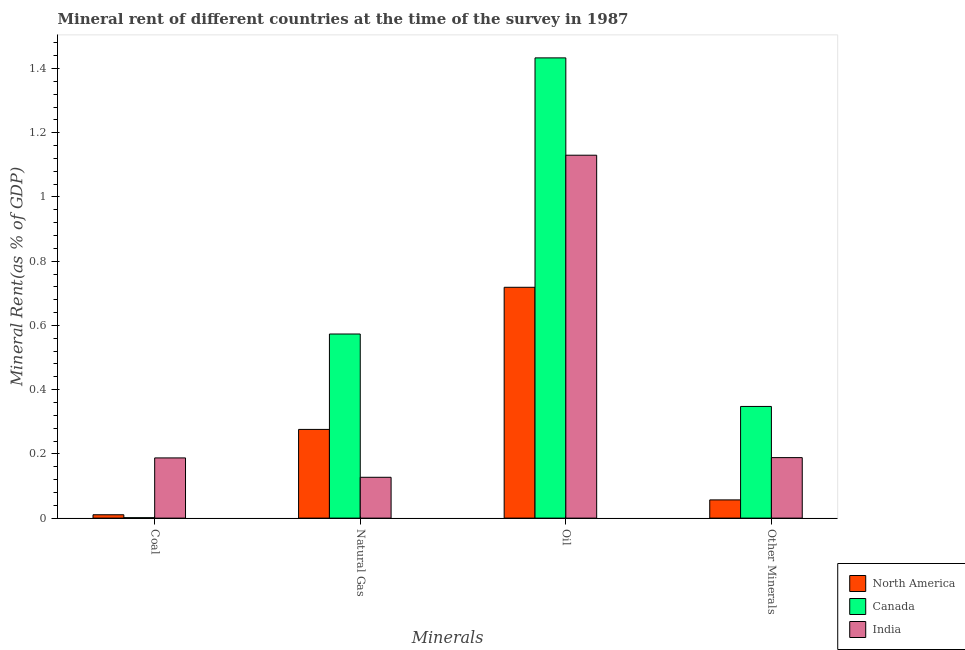How many groups of bars are there?
Your answer should be very brief. 4. Are the number of bars per tick equal to the number of legend labels?
Your answer should be very brief. Yes. How many bars are there on the 1st tick from the left?
Ensure brevity in your answer.  3. What is the label of the 3rd group of bars from the left?
Keep it short and to the point. Oil. What is the  rent of other minerals in Canada?
Give a very brief answer. 0.35. Across all countries, what is the maximum  rent of other minerals?
Ensure brevity in your answer.  0.35. Across all countries, what is the minimum coal rent?
Your answer should be very brief. 0. In which country was the coal rent minimum?
Offer a very short reply. Canada. What is the total coal rent in the graph?
Offer a terse response. 0.2. What is the difference between the coal rent in North America and that in India?
Your answer should be very brief. -0.18. What is the difference between the  rent of other minerals in India and the oil rent in North America?
Offer a very short reply. -0.53. What is the average  rent of other minerals per country?
Your answer should be compact. 0.2. What is the difference between the natural gas rent and  rent of other minerals in India?
Ensure brevity in your answer.  -0.06. What is the ratio of the oil rent in Canada to that in North America?
Provide a short and direct response. 1.99. Is the coal rent in North America less than that in Canada?
Keep it short and to the point. No. Is the difference between the natural gas rent in India and Canada greater than the difference between the  rent of other minerals in India and Canada?
Offer a very short reply. No. What is the difference between the highest and the second highest natural gas rent?
Provide a succinct answer. 0.3. What is the difference between the highest and the lowest oil rent?
Your answer should be compact. 0.71. Is the sum of the oil rent in India and Canada greater than the maximum natural gas rent across all countries?
Offer a very short reply. Yes. Is it the case that in every country, the sum of the coal rent and natural gas rent is greater than the oil rent?
Offer a very short reply. No. How many bars are there?
Your answer should be very brief. 12. Are all the bars in the graph horizontal?
Offer a very short reply. No. How many countries are there in the graph?
Give a very brief answer. 3. What is the difference between two consecutive major ticks on the Y-axis?
Offer a very short reply. 0.2. Are the values on the major ticks of Y-axis written in scientific E-notation?
Ensure brevity in your answer.  No. Does the graph contain grids?
Make the answer very short. No. What is the title of the graph?
Your answer should be very brief. Mineral rent of different countries at the time of the survey in 1987. What is the label or title of the X-axis?
Your answer should be compact. Minerals. What is the label or title of the Y-axis?
Ensure brevity in your answer.  Mineral Rent(as % of GDP). What is the Mineral Rent(as % of GDP) of North America in Coal?
Provide a succinct answer. 0.01. What is the Mineral Rent(as % of GDP) in Canada in Coal?
Give a very brief answer. 0. What is the Mineral Rent(as % of GDP) of India in Coal?
Make the answer very short. 0.19. What is the Mineral Rent(as % of GDP) of North America in Natural Gas?
Your response must be concise. 0.28. What is the Mineral Rent(as % of GDP) of Canada in Natural Gas?
Your answer should be very brief. 0.57. What is the Mineral Rent(as % of GDP) of India in Natural Gas?
Provide a short and direct response. 0.13. What is the Mineral Rent(as % of GDP) of North America in Oil?
Offer a terse response. 0.72. What is the Mineral Rent(as % of GDP) in Canada in Oil?
Your answer should be very brief. 1.43. What is the Mineral Rent(as % of GDP) of India in Oil?
Your response must be concise. 1.13. What is the Mineral Rent(as % of GDP) in North America in Other Minerals?
Provide a short and direct response. 0.06. What is the Mineral Rent(as % of GDP) in Canada in Other Minerals?
Your answer should be very brief. 0.35. What is the Mineral Rent(as % of GDP) in India in Other Minerals?
Provide a succinct answer. 0.19. Across all Minerals, what is the maximum Mineral Rent(as % of GDP) in North America?
Give a very brief answer. 0.72. Across all Minerals, what is the maximum Mineral Rent(as % of GDP) of Canada?
Offer a very short reply. 1.43. Across all Minerals, what is the maximum Mineral Rent(as % of GDP) in India?
Make the answer very short. 1.13. Across all Minerals, what is the minimum Mineral Rent(as % of GDP) of North America?
Ensure brevity in your answer.  0.01. Across all Minerals, what is the minimum Mineral Rent(as % of GDP) in Canada?
Your response must be concise. 0. Across all Minerals, what is the minimum Mineral Rent(as % of GDP) of India?
Keep it short and to the point. 0.13. What is the total Mineral Rent(as % of GDP) of North America in the graph?
Your response must be concise. 1.06. What is the total Mineral Rent(as % of GDP) of Canada in the graph?
Offer a terse response. 2.36. What is the total Mineral Rent(as % of GDP) in India in the graph?
Offer a very short reply. 1.63. What is the difference between the Mineral Rent(as % of GDP) of North America in Coal and that in Natural Gas?
Keep it short and to the point. -0.27. What is the difference between the Mineral Rent(as % of GDP) of Canada in Coal and that in Natural Gas?
Your answer should be very brief. -0.57. What is the difference between the Mineral Rent(as % of GDP) of India in Coal and that in Natural Gas?
Offer a terse response. 0.06. What is the difference between the Mineral Rent(as % of GDP) of North America in Coal and that in Oil?
Provide a succinct answer. -0.71. What is the difference between the Mineral Rent(as % of GDP) in Canada in Coal and that in Oil?
Provide a succinct answer. -1.43. What is the difference between the Mineral Rent(as % of GDP) in India in Coal and that in Oil?
Make the answer very short. -0.94. What is the difference between the Mineral Rent(as % of GDP) of North America in Coal and that in Other Minerals?
Provide a succinct answer. -0.05. What is the difference between the Mineral Rent(as % of GDP) of Canada in Coal and that in Other Minerals?
Offer a very short reply. -0.35. What is the difference between the Mineral Rent(as % of GDP) of India in Coal and that in Other Minerals?
Your response must be concise. -0. What is the difference between the Mineral Rent(as % of GDP) of North America in Natural Gas and that in Oil?
Your answer should be very brief. -0.44. What is the difference between the Mineral Rent(as % of GDP) in Canada in Natural Gas and that in Oil?
Your answer should be compact. -0.86. What is the difference between the Mineral Rent(as % of GDP) of India in Natural Gas and that in Oil?
Provide a short and direct response. -1. What is the difference between the Mineral Rent(as % of GDP) in North America in Natural Gas and that in Other Minerals?
Offer a very short reply. 0.22. What is the difference between the Mineral Rent(as % of GDP) in Canada in Natural Gas and that in Other Minerals?
Keep it short and to the point. 0.23. What is the difference between the Mineral Rent(as % of GDP) of India in Natural Gas and that in Other Minerals?
Keep it short and to the point. -0.06. What is the difference between the Mineral Rent(as % of GDP) in North America in Oil and that in Other Minerals?
Provide a succinct answer. 0.66. What is the difference between the Mineral Rent(as % of GDP) of Canada in Oil and that in Other Minerals?
Provide a short and direct response. 1.09. What is the difference between the Mineral Rent(as % of GDP) in India in Oil and that in Other Minerals?
Provide a short and direct response. 0.94. What is the difference between the Mineral Rent(as % of GDP) of North America in Coal and the Mineral Rent(as % of GDP) of Canada in Natural Gas?
Keep it short and to the point. -0.56. What is the difference between the Mineral Rent(as % of GDP) in North America in Coal and the Mineral Rent(as % of GDP) in India in Natural Gas?
Keep it short and to the point. -0.12. What is the difference between the Mineral Rent(as % of GDP) in Canada in Coal and the Mineral Rent(as % of GDP) in India in Natural Gas?
Your response must be concise. -0.13. What is the difference between the Mineral Rent(as % of GDP) of North America in Coal and the Mineral Rent(as % of GDP) of Canada in Oil?
Keep it short and to the point. -1.42. What is the difference between the Mineral Rent(as % of GDP) of North America in Coal and the Mineral Rent(as % of GDP) of India in Oil?
Offer a very short reply. -1.12. What is the difference between the Mineral Rent(as % of GDP) of Canada in Coal and the Mineral Rent(as % of GDP) of India in Oil?
Provide a succinct answer. -1.13. What is the difference between the Mineral Rent(as % of GDP) of North America in Coal and the Mineral Rent(as % of GDP) of Canada in Other Minerals?
Provide a short and direct response. -0.34. What is the difference between the Mineral Rent(as % of GDP) of North America in Coal and the Mineral Rent(as % of GDP) of India in Other Minerals?
Provide a short and direct response. -0.18. What is the difference between the Mineral Rent(as % of GDP) in Canada in Coal and the Mineral Rent(as % of GDP) in India in Other Minerals?
Provide a succinct answer. -0.19. What is the difference between the Mineral Rent(as % of GDP) in North America in Natural Gas and the Mineral Rent(as % of GDP) in Canada in Oil?
Keep it short and to the point. -1.16. What is the difference between the Mineral Rent(as % of GDP) of North America in Natural Gas and the Mineral Rent(as % of GDP) of India in Oil?
Provide a succinct answer. -0.85. What is the difference between the Mineral Rent(as % of GDP) of Canada in Natural Gas and the Mineral Rent(as % of GDP) of India in Oil?
Make the answer very short. -0.56. What is the difference between the Mineral Rent(as % of GDP) in North America in Natural Gas and the Mineral Rent(as % of GDP) in Canada in Other Minerals?
Keep it short and to the point. -0.07. What is the difference between the Mineral Rent(as % of GDP) of North America in Natural Gas and the Mineral Rent(as % of GDP) of India in Other Minerals?
Your answer should be very brief. 0.09. What is the difference between the Mineral Rent(as % of GDP) of Canada in Natural Gas and the Mineral Rent(as % of GDP) of India in Other Minerals?
Make the answer very short. 0.38. What is the difference between the Mineral Rent(as % of GDP) in North America in Oil and the Mineral Rent(as % of GDP) in Canada in Other Minerals?
Ensure brevity in your answer.  0.37. What is the difference between the Mineral Rent(as % of GDP) of North America in Oil and the Mineral Rent(as % of GDP) of India in Other Minerals?
Give a very brief answer. 0.53. What is the difference between the Mineral Rent(as % of GDP) in Canada in Oil and the Mineral Rent(as % of GDP) in India in Other Minerals?
Your answer should be compact. 1.24. What is the average Mineral Rent(as % of GDP) of North America per Minerals?
Your answer should be compact. 0.27. What is the average Mineral Rent(as % of GDP) in Canada per Minerals?
Your answer should be very brief. 0.59. What is the average Mineral Rent(as % of GDP) of India per Minerals?
Offer a very short reply. 0.41. What is the difference between the Mineral Rent(as % of GDP) of North America and Mineral Rent(as % of GDP) of Canada in Coal?
Offer a terse response. 0.01. What is the difference between the Mineral Rent(as % of GDP) in North America and Mineral Rent(as % of GDP) in India in Coal?
Offer a terse response. -0.18. What is the difference between the Mineral Rent(as % of GDP) of Canada and Mineral Rent(as % of GDP) of India in Coal?
Your answer should be compact. -0.19. What is the difference between the Mineral Rent(as % of GDP) of North America and Mineral Rent(as % of GDP) of Canada in Natural Gas?
Give a very brief answer. -0.3. What is the difference between the Mineral Rent(as % of GDP) in North America and Mineral Rent(as % of GDP) in India in Natural Gas?
Make the answer very short. 0.15. What is the difference between the Mineral Rent(as % of GDP) of Canada and Mineral Rent(as % of GDP) of India in Natural Gas?
Your response must be concise. 0.45. What is the difference between the Mineral Rent(as % of GDP) in North America and Mineral Rent(as % of GDP) in Canada in Oil?
Keep it short and to the point. -0.71. What is the difference between the Mineral Rent(as % of GDP) in North America and Mineral Rent(as % of GDP) in India in Oil?
Your answer should be very brief. -0.41. What is the difference between the Mineral Rent(as % of GDP) of Canada and Mineral Rent(as % of GDP) of India in Oil?
Offer a very short reply. 0.3. What is the difference between the Mineral Rent(as % of GDP) in North America and Mineral Rent(as % of GDP) in Canada in Other Minerals?
Ensure brevity in your answer.  -0.29. What is the difference between the Mineral Rent(as % of GDP) in North America and Mineral Rent(as % of GDP) in India in Other Minerals?
Your answer should be very brief. -0.13. What is the difference between the Mineral Rent(as % of GDP) in Canada and Mineral Rent(as % of GDP) in India in Other Minerals?
Keep it short and to the point. 0.16. What is the ratio of the Mineral Rent(as % of GDP) in North America in Coal to that in Natural Gas?
Keep it short and to the point. 0.04. What is the ratio of the Mineral Rent(as % of GDP) in Canada in Coal to that in Natural Gas?
Your response must be concise. 0. What is the ratio of the Mineral Rent(as % of GDP) of India in Coal to that in Natural Gas?
Offer a terse response. 1.47. What is the ratio of the Mineral Rent(as % of GDP) in North America in Coal to that in Oil?
Offer a terse response. 0.01. What is the ratio of the Mineral Rent(as % of GDP) of Canada in Coal to that in Oil?
Your answer should be very brief. 0. What is the ratio of the Mineral Rent(as % of GDP) in India in Coal to that in Oil?
Make the answer very short. 0.17. What is the ratio of the Mineral Rent(as % of GDP) of North America in Coal to that in Other Minerals?
Make the answer very short. 0.18. What is the ratio of the Mineral Rent(as % of GDP) in Canada in Coal to that in Other Minerals?
Your answer should be compact. 0. What is the ratio of the Mineral Rent(as % of GDP) in North America in Natural Gas to that in Oil?
Your answer should be very brief. 0.38. What is the ratio of the Mineral Rent(as % of GDP) in Canada in Natural Gas to that in Oil?
Your answer should be compact. 0.4. What is the ratio of the Mineral Rent(as % of GDP) in India in Natural Gas to that in Oil?
Offer a very short reply. 0.11. What is the ratio of the Mineral Rent(as % of GDP) in North America in Natural Gas to that in Other Minerals?
Give a very brief answer. 4.87. What is the ratio of the Mineral Rent(as % of GDP) in Canada in Natural Gas to that in Other Minerals?
Ensure brevity in your answer.  1.65. What is the ratio of the Mineral Rent(as % of GDP) of India in Natural Gas to that in Other Minerals?
Your answer should be very brief. 0.68. What is the ratio of the Mineral Rent(as % of GDP) of North America in Oil to that in Other Minerals?
Offer a very short reply. 12.67. What is the ratio of the Mineral Rent(as % of GDP) in Canada in Oil to that in Other Minerals?
Provide a short and direct response. 4.12. What is the ratio of the Mineral Rent(as % of GDP) of India in Oil to that in Other Minerals?
Offer a terse response. 6. What is the difference between the highest and the second highest Mineral Rent(as % of GDP) in North America?
Your answer should be compact. 0.44. What is the difference between the highest and the second highest Mineral Rent(as % of GDP) in Canada?
Provide a short and direct response. 0.86. What is the difference between the highest and the second highest Mineral Rent(as % of GDP) in India?
Your response must be concise. 0.94. What is the difference between the highest and the lowest Mineral Rent(as % of GDP) in North America?
Your answer should be very brief. 0.71. What is the difference between the highest and the lowest Mineral Rent(as % of GDP) of Canada?
Ensure brevity in your answer.  1.43. What is the difference between the highest and the lowest Mineral Rent(as % of GDP) of India?
Offer a very short reply. 1. 